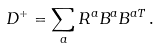<formula> <loc_0><loc_0><loc_500><loc_500>D ^ { + } = \sum _ { a } R ^ { a } B ^ { a } B ^ { a T } \, .</formula> 